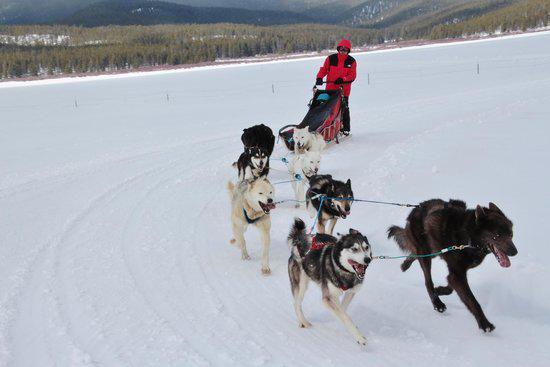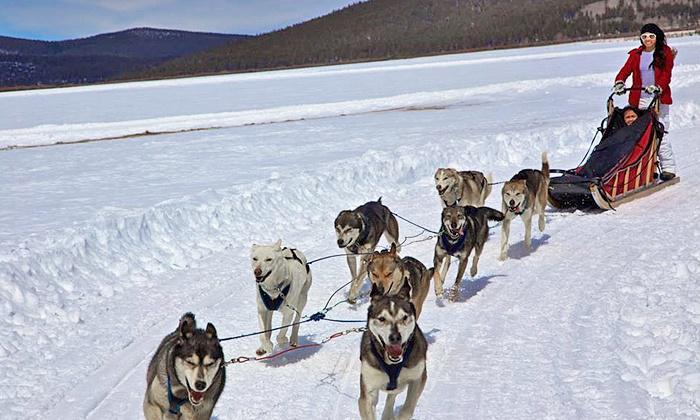The first image is the image on the left, the second image is the image on the right. For the images displayed, is the sentence "Both riders are wearing red jackets." factually correct? Answer yes or no. Yes. The first image is the image on the left, the second image is the image on the right. Considering the images on both sides, is "The sled dog teams in the two images are heading in the same direction on a non-curved path." valid? Answer yes or no. No. 